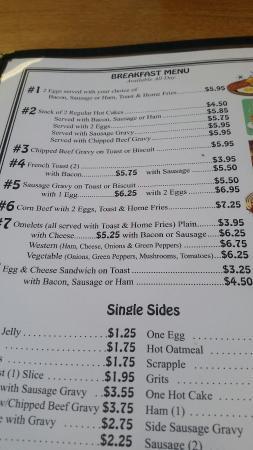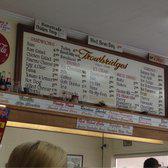The first image is the image on the left, the second image is the image on the right. Examine the images to the left and right. Is the description "Both images contain menus." accurate? Answer yes or no. Yes. The first image is the image on the left, the second image is the image on the right. Examine the images to the left and right. Is the description "The right image shows a diner exterior with a rectangular sign over glass windows in front of a parking lot." accurate? Answer yes or no. No. 